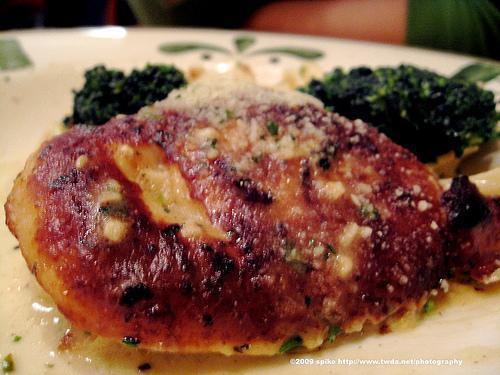How many broccolis can be seen?
Give a very brief answer. 2. 